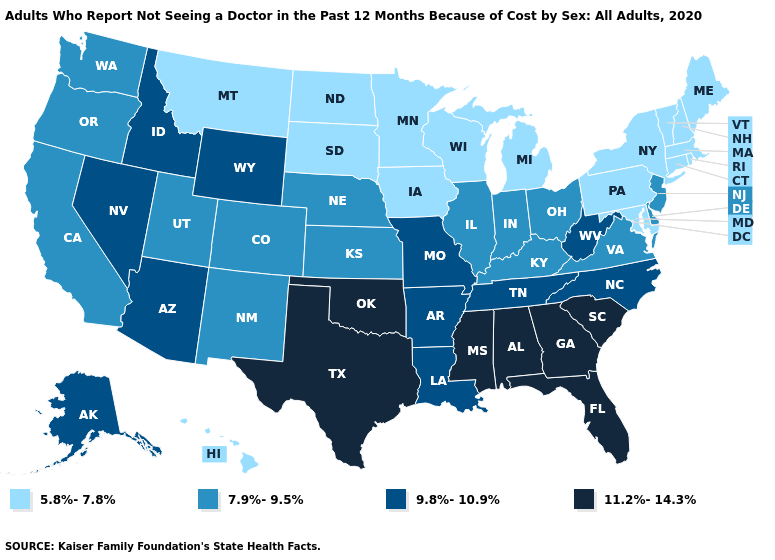What is the value of Virginia?
Keep it brief. 7.9%-9.5%. Name the states that have a value in the range 9.8%-10.9%?
Quick response, please. Alaska, Arizona, Arkansas, Idaho, Louisiana, Missouri, Nevada, North Carolina, Tennessee, West Virginia, Wyoming. Among the states that border Massachusetts , which have the highest value?
Be succinct. Connecticut, New Hampshire, New York, Rhode Island, Vermont. Which states have the lowest value in the MidWest?
Short answer required. Iowa, Michigan, Minnesota, North Dakota, South Dakota, Wisconsin. Among the states that border Wyoming , which have the highest value?
Be succinct. Idaho. What is the lowest value in the USA?
Short answer required. 5.8%-7.8%. Name the states that have a value in the range 11.2%-14.3%?
Concise answer only. Alabama, Florida, Georgia, Mississippi, Oklahoma, South Carolina, Texas. What is the lowest value in the MidWest?
Be succinct. 5.8%-7.8%. Does Florida have the highest value in the USA?
Quick response, please. Yes. Among the states that border Texas , which have the highest value?
Write a very short answer. Oklahoma. Name the states that have a value in the range 7.9%-9.5%?
Concise answer only. California, Colorado, Delaware, Illinois, Indiana, Kansas, Kentucky, Nebraska, New Jersey, New Mexico, Ohio, Oregon, Utah, Virginia, Washington. What is the value of New Jersey?
Be succinct. 7.9%-9.5%. Does the map have missing data?
Keep it brief. No. What is the highest value in states that border California?
Answer briefly. 9.8%-10.9%. Does Mississippi have the highest value in the USA?
Answer briefly. Yes. 